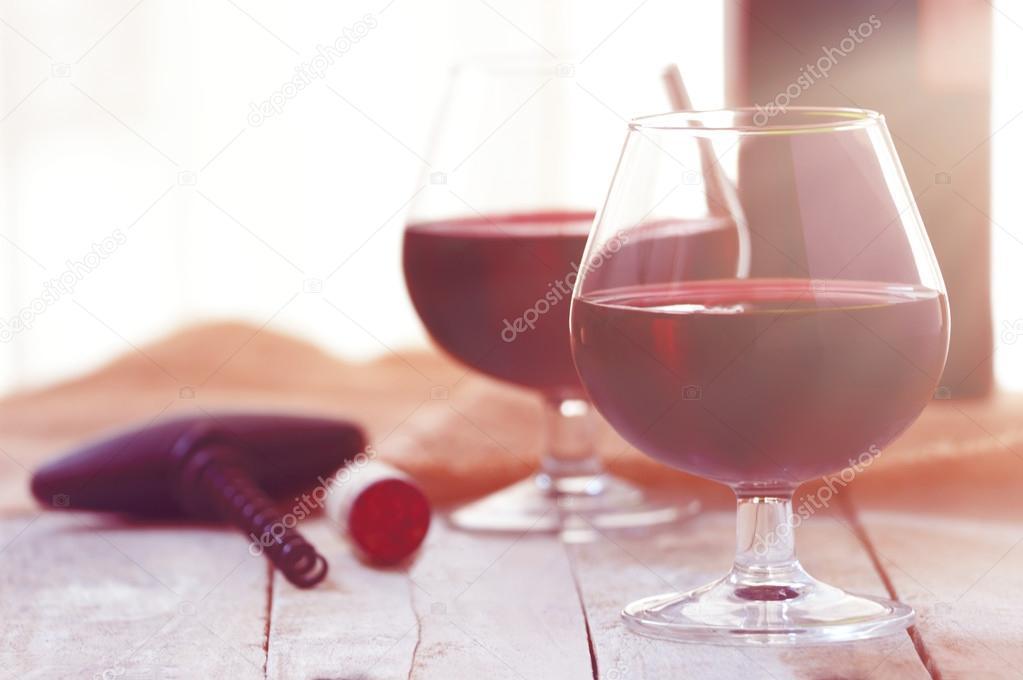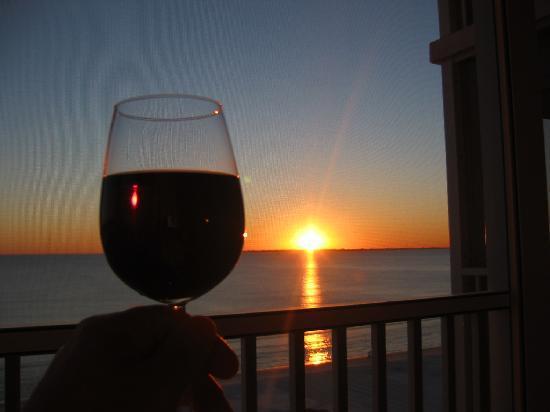The first image is the image on the left, the second image is the image on the right. For the images displayed, is the sentence "At least one image contains a wine bottle, being poured into a glass, with a sunset in the background." factually correct? Answer yes or no. No. The first image is the image on the left, the second image is the image on the right. For the images displayed, is the sentence "In one image, red wine is being poured into a wine glass" factually correct? Answer yes or no. No. 